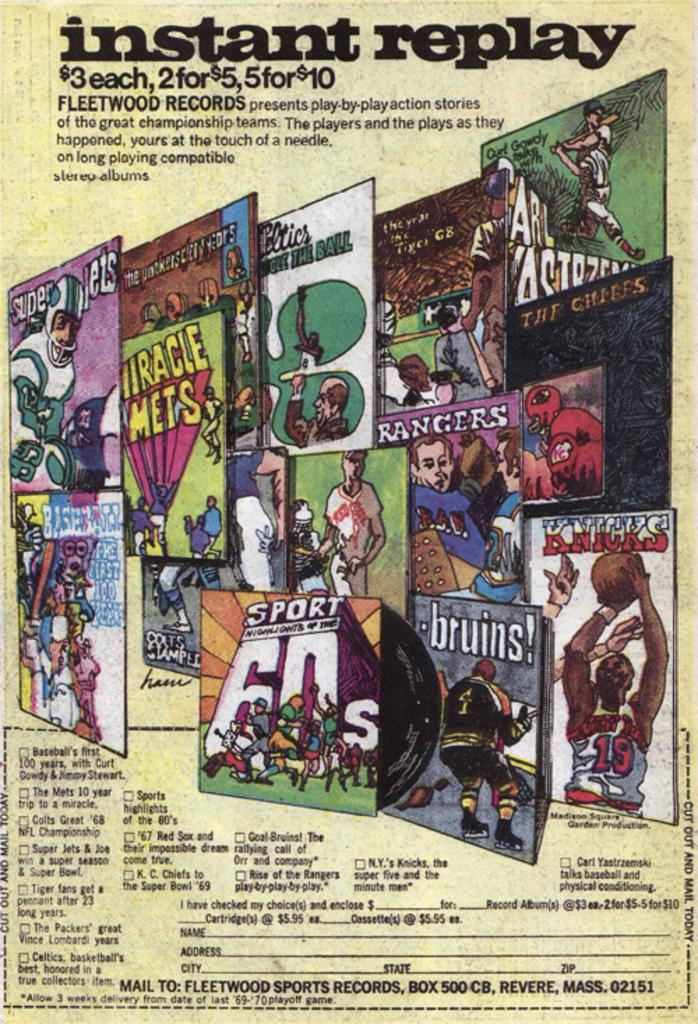<image>
Write a terse but informative summary of the picture. Instant replay album advertisement with several sports figures on the cover. 